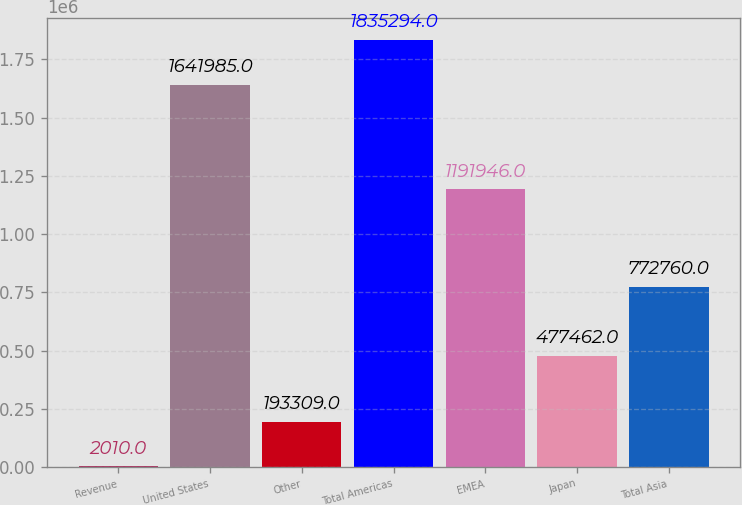<chart> <loc_0><loc_0><loc_500><loc_500><bar_chart><fcel>Revenue<fcel>United States<fcel>Other<fcel>Total Americas<fcel>EMEA<fcel>Japan<fcel>Total Asia<nl><fcel>2010<fcel>1.64198e+06<fcel>193309<fcel>1.83529e+06<fcel>1.19195e+06<fcel>477462<fcel>772760<nl></chart> 